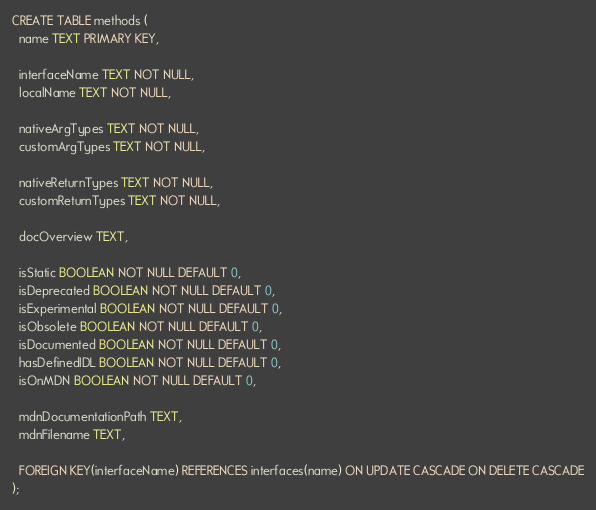Convert code to text. <code><loc_0><loc_0><loc_500><loc_500><_SQL_>CREATE TABLE methods (
  name TEXT PRIMARY KEY,

  interfaceName TEXT NOT NULL,
  localName TEXT NOT NULL,

  nativeArgTypes TEXT NOT NULL,
  customArgTypes TEXT NOT NULL,

  nativeReturnTypes TEXT NOT NULL,
  customReturnTypes TEXT NOT NULL,

  docOverview TEXT,

  isStatic BOOLEAN NOT NULL DEFAULT 0,
  isDeprecated BOOLEAN NOT NULL DEFAULT 0,
  isExperimental BOOLEAN NOT NULL DEFAULT 0,
  isObsolete BOOLEAN NOT NULL DEFAULT 0,
  isDocumented BOOLEAN NOT NULL DEFAULT 0,
  hasDefinedIDL BOOLEAN NOT NULL DEFAULT 0,
  isOnMDN BOOLEAN NOT NULL DEFAULT 0,

  mdnDocumentationPath TEXT,
  mdnFilename TEXT,

  FOREIGN KEY(interfaceName) REFERENCES interfaces(name) ON UPDATE CASCADE ON DELETE CASCADE
);
</code> 